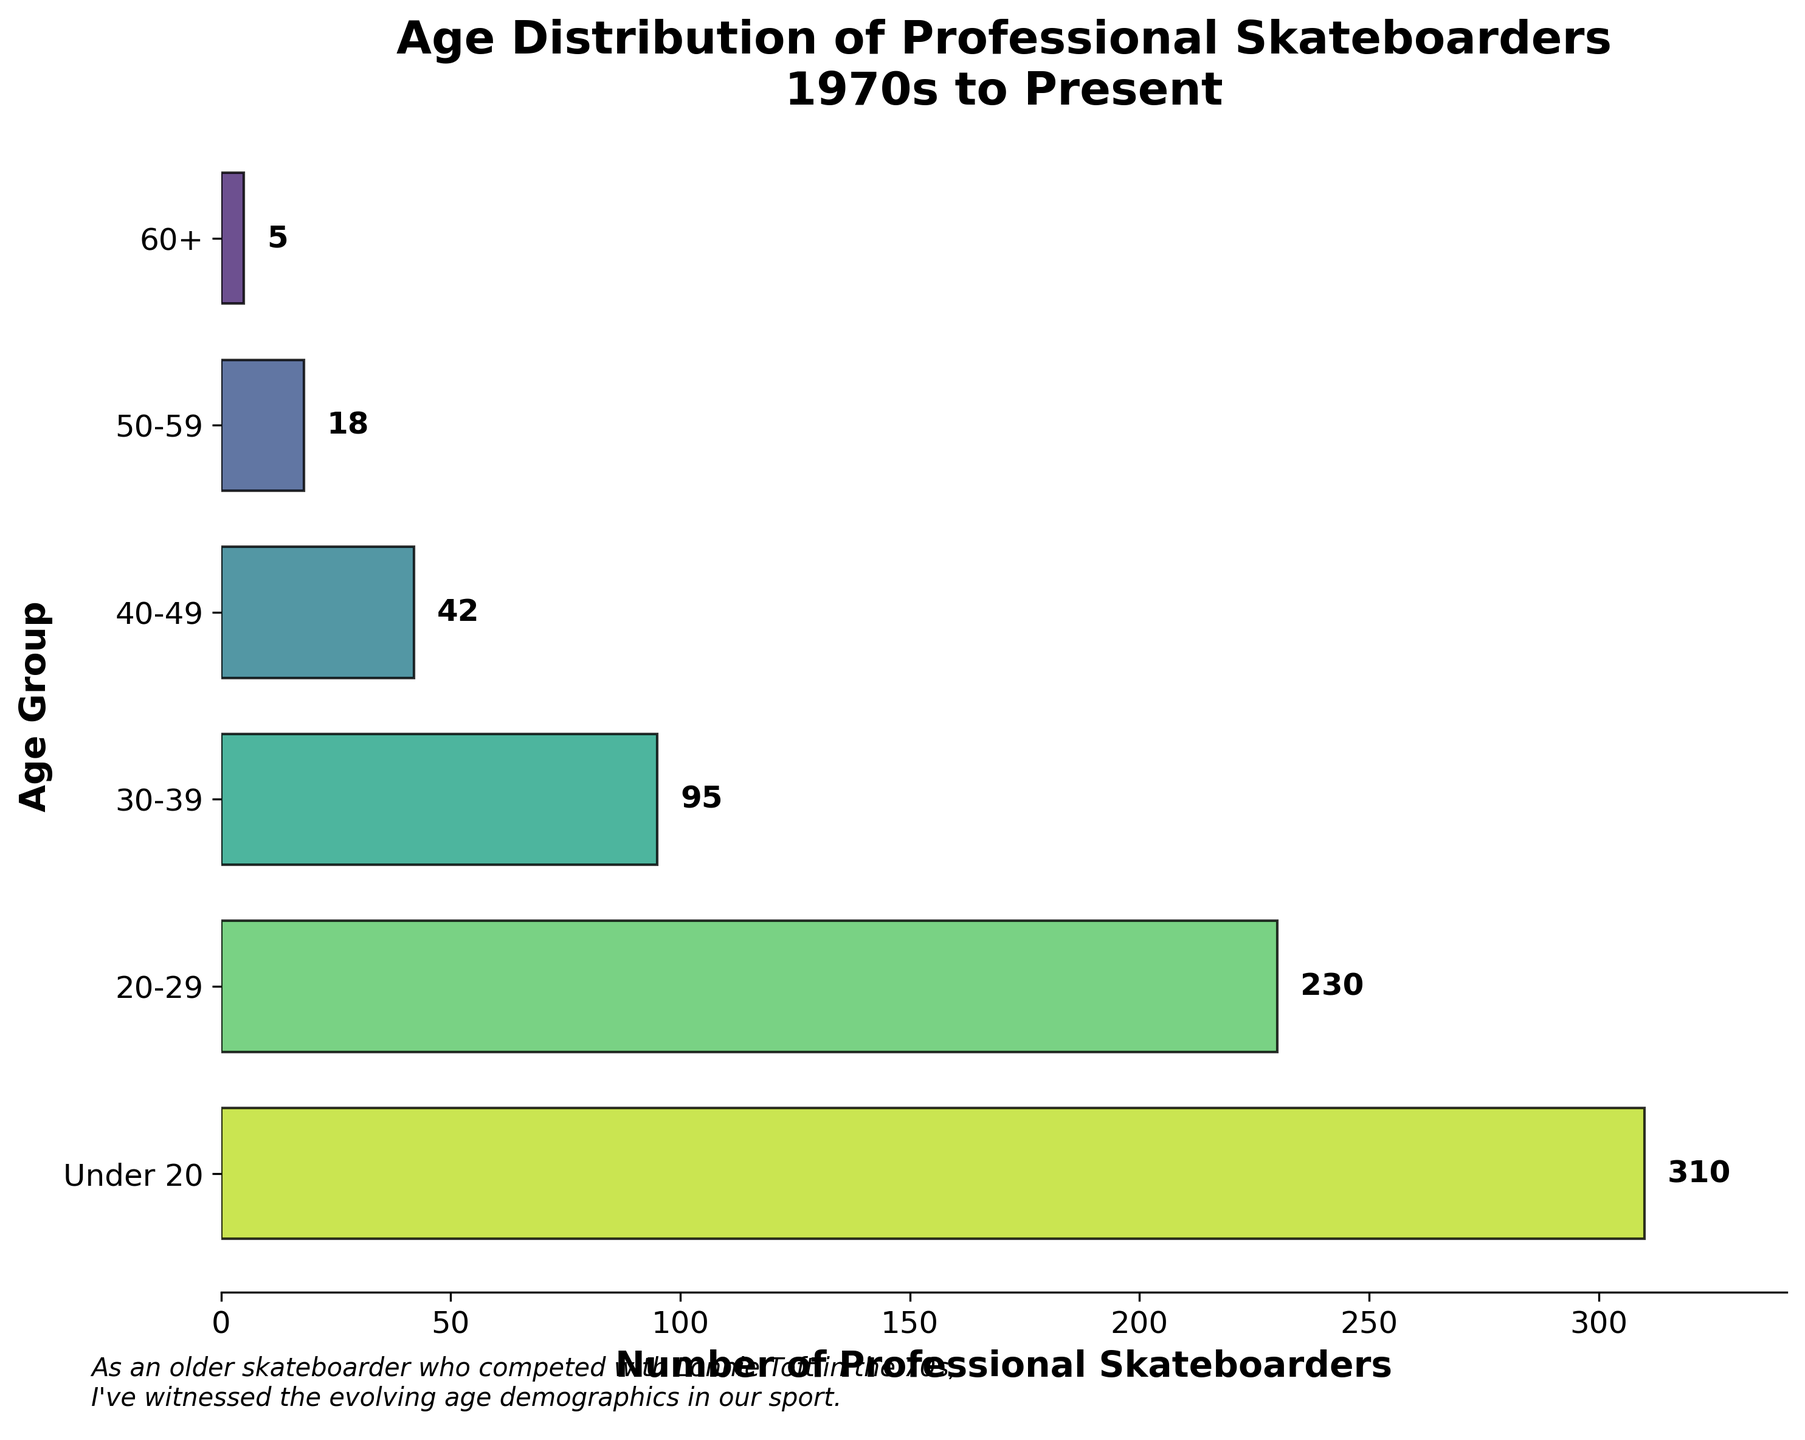What's the age group with the highest number of professional skateboarders? The figure shows that the "Under 20" age group has the tallest bar, which indicates it has the highest number.
Answer: Under 20 Which age group has the fewest professional skateboarders? The "60+" age group has the shortest bar, indicating it has the fewest professional skateboarders.
Answer: 60+ What's the total number of professional skateboarders in age groups above 40? Add the numbers of skateboarders in the 40-49, 50-59, and 60+ age groups: 42 + 18 + 5.
Answer: 65 How many more professional skateboarders are there in the 20-29 age group compared to the 50-59 age group? Subtract the number in the 50-59 age group from the 20-29 age group: 230 - 18.
Answer: 212 What is the difference in the number of skateboarders between the Under 20 and 60+ age groups? Subtract the number in the 60+ age group from the Under 20 group: 310 - 5.
Answer: 305 How does the number of professional skateboarders in the 30-39 age group compare to the 40-49 age group? Compare the numbers: The 30-39 age group has 95 while the 40-49 age group has 42, so 30-39 has more.
Answer: 30-39 has more What's the average number of skateboarders in all age groups combined? First, find the total by adding all numbers: 5 + 18 + 42 + 95 + 230 + 310. Then divide by the number of age groups, which is 6.
Answer: 700/6 ≈ 117 Which age group has approximately half the number of skateboarders as the 30-39 age group? The 30-39 group has 95 skateboarders. Half of 95 is approximately 47.5. The 40-49 group has 42, which is close to 47.5.
Answer: 40-49 Are there more professional skateboarders under 30 or over 30? Add the numbers in the Under 20 and 20-29 groups (310 + 230) and compare to the total of the 30-39, 40-49, 50-59, and 60+ groups (95 + 42 + 18 + 5). The under 30 total equals 540, while the over 30 total equals 160.
Answer: Under 30 